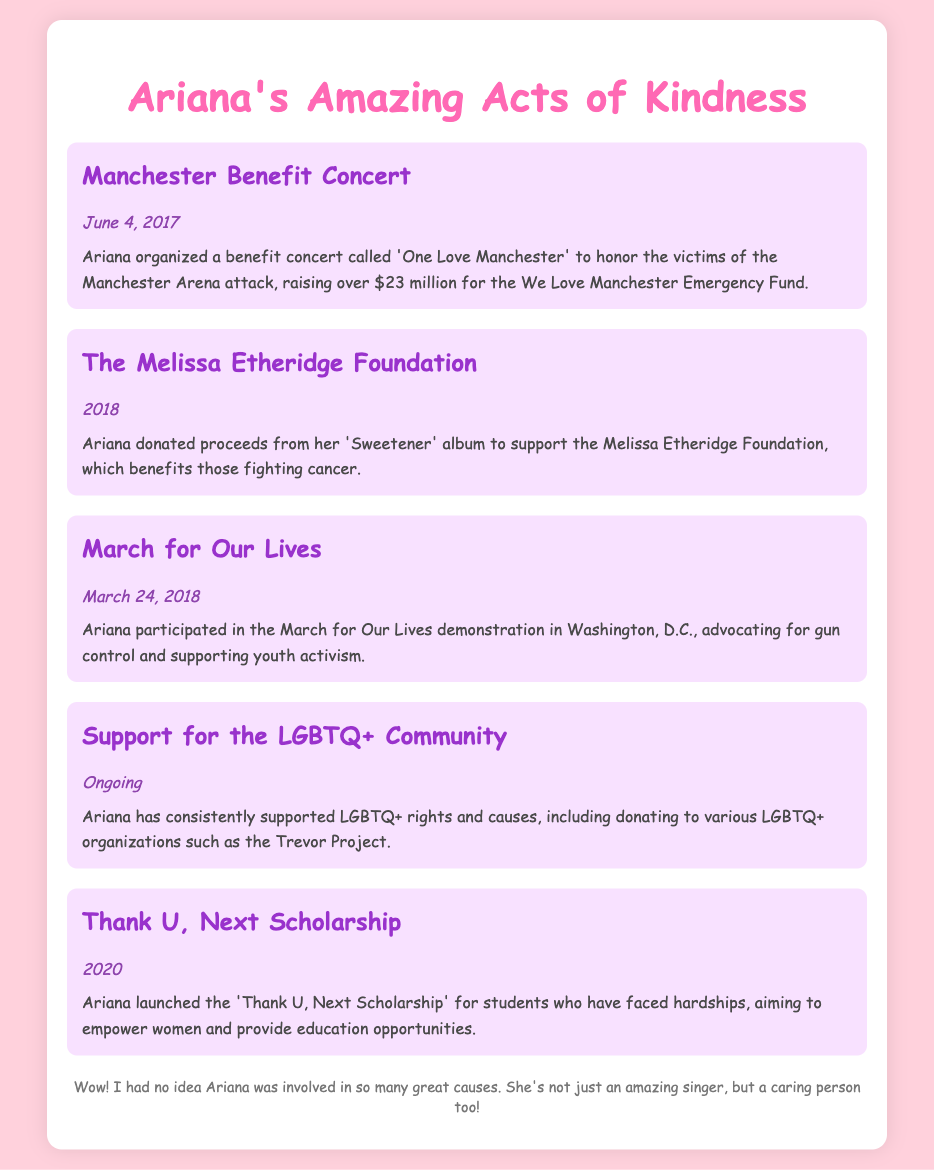What was the name of the benefit concert Ariana organized in 2017? The document states that the benefit concert was called 'One Love Manchester.'
Answer: One Love Manchester How much money did Ariana raise at the Manchester Benefit Concert? According to the document, Ariana raised over $23 million for the We Love Manchester Emergency Fund.
Answer: $23 million In what year did Ariana support the Melissa Etheridge Foundation? The document mentions that Ariana donated proceeds in 2018.
Answer: 2018 What cause did Ariana advocate for during the March for Our Lives demonstration? The document indicates that Ariana advocated for gun control and supported youth activism.
Answer: Gun control What scholarship did Ariana launch in 2020? The document details that she launched the 'Thank U, Next Scholarship.'
Answer: Thank U, Next Scholarship What ongoing support does Ariana provide for the LGBTQ+ community? The document mentions that she has consistently supported LGBTQ+ rights and causes.
Answer: LGBTQ+ rights What is the aim of the Thank U, Next Scholarship? The document states that the scholarship aims to empower women and provide educational opportunities.
Answer: Empower women Which organization did Ariana donate to that benefits people fighting cancer? The document states that the Melissa Etheridge Foundation is the organization she donated to.
Answer: Melissa Etheridge Foundation When did Ariana participate in the March for Our Lives? The document specifies that Ariana participated on March 24, 2018.
Answer: March 24, 2018 